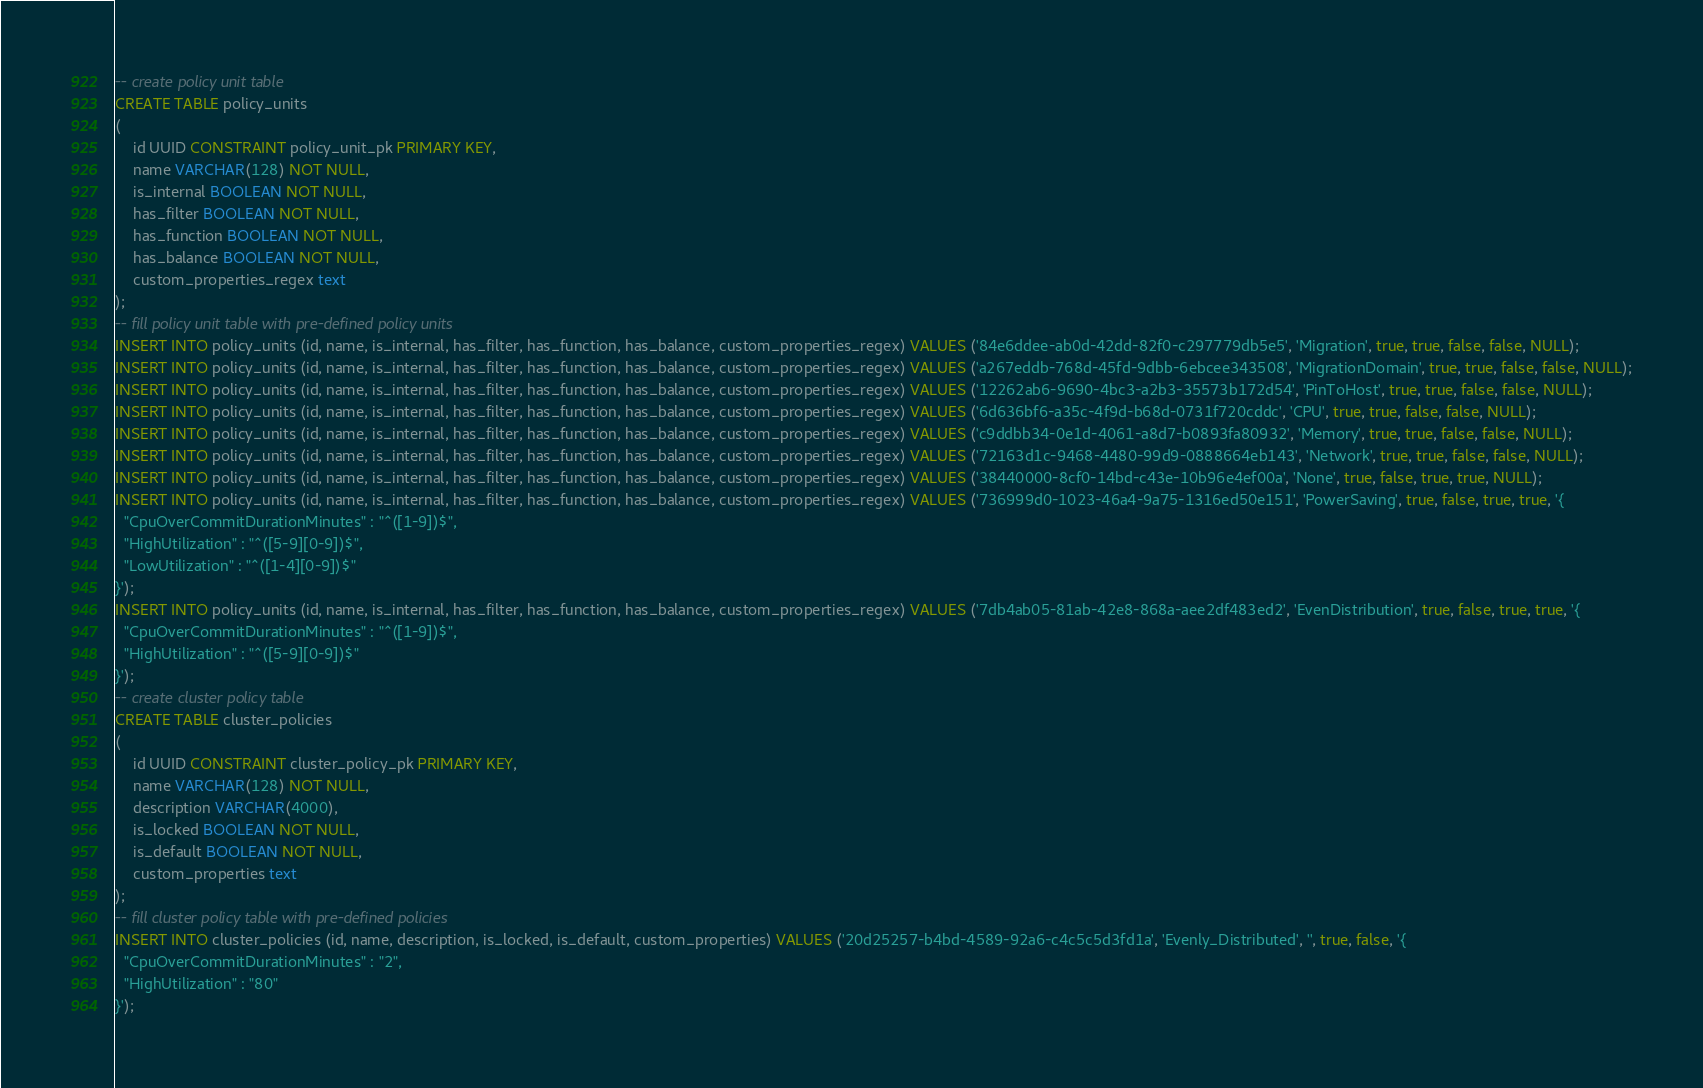<code> <loc_0><loc_0><loc_500><loc_500><_SQL_>-- create policy unit table
CREATE TABLE policy_units
(
    id UUID CONSTRAINT policy_unit_pk PRIMARY KEY,
    name VARCHAR(128) NOT NULL,
    is_internal BOOLEAN NOT NULL,
    has_filter BOOLEAN NOT NULL,
    has_function BOOLEAN NOT NULL,
    has_balance BOOLEAN NOT NULL,
    custom_properties_regex text
);
-- fill policy unit table with pre-defined policy units
INSERT INTO policy_units (id, name, is_internal, has_filter, has_function, has_balance, custom_properties_regex) VALUES ('84e6ddee-ab0d-42dd-82f0-c297779db5e5', 'Migration', true, true, false, false, NULL);
INSERT INTO policy_units (id, name, is_internal, has_filter, has_function, has_balance, custom_properties_regex) VALUES ('a267eddb-768d-45fd-9dbb-6ebcee343508', 'MigrationDomain', true, true, false, false, NULL);
INSERT INTO policy_units (id, name, is_internal, has_filter, has_function, has_balance, custom_properties_regex) VALUES ('12262ab6-9690-4bc3-a2b3-35573b172d54', 'PinToHost', true, true, false, false, NULL);
INSERT INTO policy_units (id, name, is_internal, has_filter, has_function, has_balance, custom_properties_regex) VALUES ('6d636bf6-a35c-4f9d-b68d-0731f720cddc', 'CPU', true, true, false, false, NULL);
INSERT INTO policy_units (id, name, is_internal, has_filter, has_function, has_balance, custom_properties_regex) VALUES ('c9ddbb34-0e1d-4061-a8d7-b0893fa80932', 'Memory', true, true, false, false, NULL);
INSERT INTO policy_units (id, name, is_internal, has_filter, has_function, has_balance, custom_properties_regex) VALUES ('72163d1c-9468-4480-99d9-0888664eb143', 'Network', true, true, false, false, NULL);
INSERT INTO policy_units (id, name, is_internal, has_filter, has_function, has_balance, custom_properties_regex) VALUES ('38440000-8cf0-14bd-c43e-10b96e4ef00a', 'None', true, false, true, true, NULL);
INSERT INTO policy_units (id, name, is_internal, has_filter, has_function, has_balance, custom_properties_regex) VALUES ('736999d0-1023-46a4-9a75-1316ed50e151', 'PowerSaving', true, false, true, true, '{
  "CpuOverCommitDurationMinutes" : "^([1-9])$",
  "HighUtilization" : "^([5-9][0-9])$",
  "LowUtilization" : "^([1-4][0-9])$"
}');
INSERT INTO policy_units (id, name, is_internal, has_filter, has_function, has_balance, custom_properties_regex) VALUES ('7db4ab05-81ab-42e8-868a-aee2df483ed2', 'EvenDistribution', true, false, true, true, '{
  "CpuOverCommitDurationMinutes" : "^([1-9])$",
  "HighUtilization" : "^([5-9][0-9])$"
}');
-- create cluster policy table
CREATE TABLE cluster_policies
(
    id UUID CONSTRAINT cluster_policy_pk PRIMARY KEY,
    name VARCHAR(128) NOT NULL,
    description VARCHAR(4000),
    is_locked BOOLEAN NOT NULL,
    is_default BOOLEAN NOT NULL,
    custom_properties text
);
-- fill cluster policy table with pre-defined policies
INSERT INTO cluster_policies (id, name, description, is_locked, is_default, custom_properties) VALUES ('20d25257-b4bd-4589-92a6-c4c5c5d3fd1a', 'Evenly_Distributed', '', true, false, '{
  "CpuOverCommitDurationMinutes" : "2",
  "HighUtilization" : "80"
}');</code> 